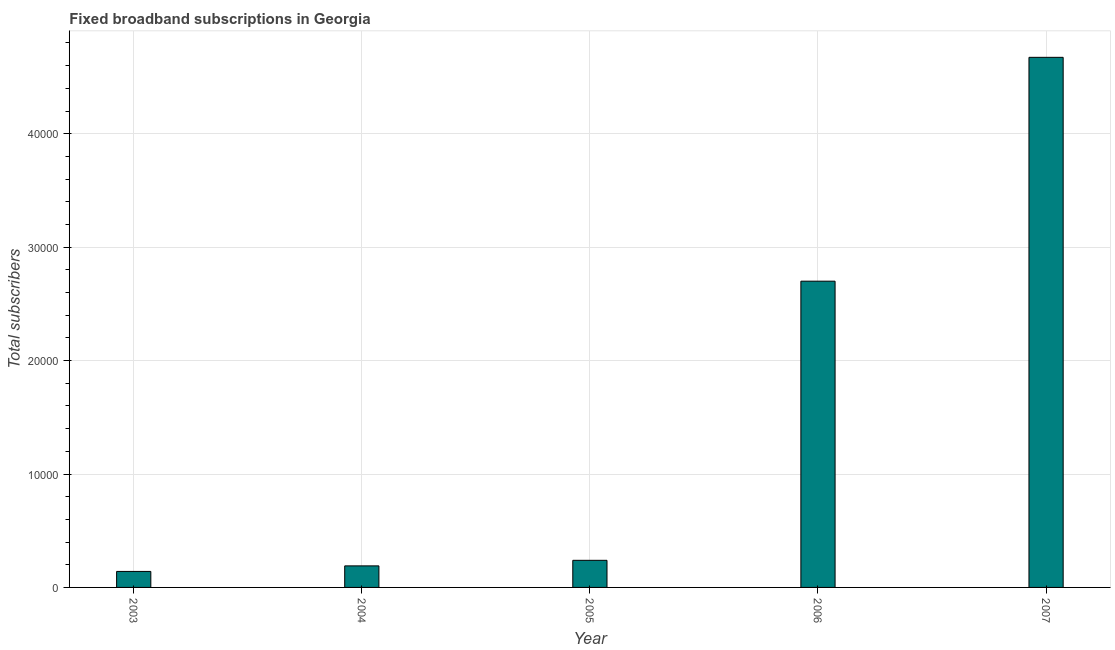Does the graph contain any zero values?
Keep it short and to the point. No. What is the title of the graph?
Offer a terse response. Fixed broadband subscriptions in Georgia. What is the label or title of the X-axis?
Your answer should be compact. Year. What is the label or title of the Y-axis?
Give a very brief answer. Total subscribers. What is the total number of fixed broadband subscriptions in 2004?
Offer a very short reply. 1900. Across all years, what is the maximum total number of fixed broadband subscriptions?
Provide a succinct answer. 4.67e+04. Across all years, what is the minimum total number of fixed broadband subscriptions?
Your response must be concise. 1410. What is the sum of the total number of fixed broadband subscriptions?
Your answer should be compact. 7.94e+04. What is the difference between the total number of fixed broadband subscriptions in 2004 and 2007?
Your answer should be compact. -4.48e+04. What is the average total number of fixed broadband subscriptions per year?
Your response must be concise. 1.59e+04. What is the median total number of fixed broadband subscriptions?
Your answer should be very brief. 2390. In how many years, is the total number of fixed broadband subscriptions greater than 4000 ?
Give a very brief answer. 2. Do a majority of the years between 2004 and 2005 (inclusive) have total number of fixed broadband subscriptions greater than 12000 ?
Your answer should be very brief. No. What is the ratio of the total number of fixed broadband subscriptions in 2003 to that in 2004?
Your answer should be very brief. 0.74. Is the difference between the total number of fixed broadband subscriptions in 2004 and 2006 greater than the difference between any two years?
Make the answer very short. No. What is the difference between the highest and the second highest total number of fixed broadband subscriptions?
Offer a terse response. 1.97e+04. What is the difference between the highest and the lowest total number of fixed broadband subscriptions?
Offer a very short reply. 4.53e+04. In how many years, is the total number of fixed broadband subscriptions greater than the average total number of fixed broadband subscriptions taken over all years?
Your response must be concise. 2. What is the difference between two consecutive major ticks on the Y-axis?
Provide a succinct answer. 10000. What is the Total subscribers in 2003?
Provide a short and direct response. 1410. What is the Total subscribers of 2004?
Offer a very short reply. 1900. What is the Total subscribers in 2005?
Provide a short and direct response. 2390. What is the Total subscribers of 2006?
Make the answer very short. 2.70e+04. What is the Total subscribers of 2007?
Your answer should be compact. 4.67e+04. What is the difference between the Total subscribers in 2003 and 2004?
Provide a short and direct response. -490. What is the difference between the Total subscribers in 2003 and 2005?
Your response must be concise. -980. What is the difference between the Total subscribers in 2003 and 2006?
Offer a very short reply. -2.56e+04. What is the difference between the Total subscribers in 2003 and 2007?
Provide a succinct answer. -4.53e+04. What is the difference between the Total subscribers in 2004 and 2005?
Your response must be concise. -490. What is the difference between the Total subscribers in 2004 and 2006?
Provide a succinct answer. -2.51e+04. What is the difference between the Total subscribers in 2004 and 2007?
Offer a terse response. -4.48e+04. What is the difference between the Total subscribers in 2005 and 2006?
Your answer should be compact. -2.46e+04. What is the difference between the Total subscribers in 2005 and 2007?
Ensure brevity in your answer.  -4.43e+04. What is the difference between the Total subscribers in 2006 and 2007?
Provide a short and direct response. -1.97e+04. What is the ratio of the Total subscribers in 2003 to that in 2004?
Your response must be concise. 0.74. What is the ratio of the Total subscribers in 2003 to that in 2005?
Your answer should be compact. 0.59. What is the ratio of the Total subscribers in 2003 to that in 2006?
Your response must be concise. 0.05. What is the ratio of the Total subscribers in 2004 to that in 2005?
Your response must be concise. 0.8. What is the ratio of the Total subscribers in 2004 to that in 2006?
Keep it short and to the point. 0.07. What is the ratio of the Total subscribers in 2004 to that in 2007?
Your answer should be compact. 0.04. What is the ratio of the Total subscribers in 2005 to that in 2006?
Provide a succinct answer. 0.09. What is the ratio of the Total subscribers in 2005 to that in 2007?
Give a very brief answer. 0.05. What is the ratio of the Total subscribers in 2006 to that in 2007?
Offer a terse response. 0.58. 